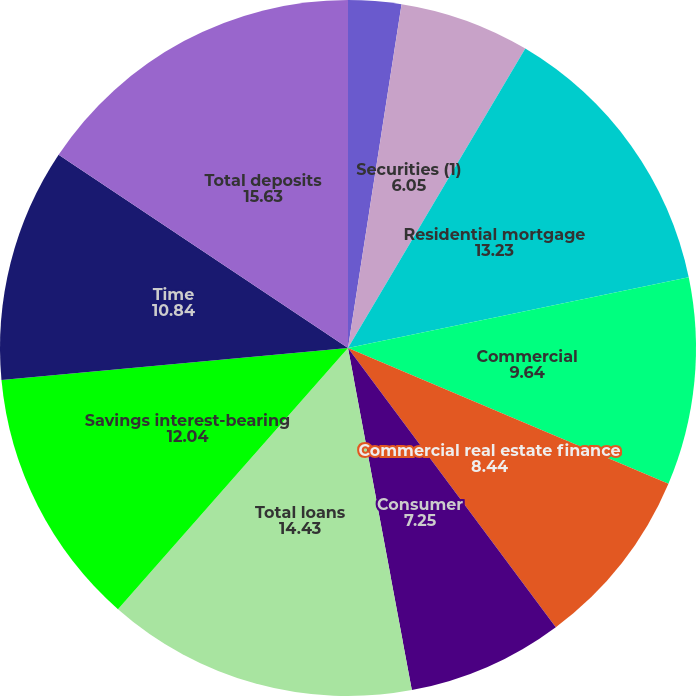<chart> <loc_0><loc_0><loc_500><loc_500><pie_chart><fcel>Short-term investments<fcel>Securities (1)<fcel>Residential mortgage<fcel>Commercial<fcel>Commercial real estate finance<fcel>Consumer<fcel>Total loans<fcel>Savings interest-bearing<fcel>Time<fcel>Total deposits<nl><fcel>2.46%<fcel>6.05%<fcel>13.23%<fcel>9.64%<fcel>8.44%<fcel>7.25%<fcel>14.43%<fcel>12.04%<fcel>10.84%<fcel>15.63%<nl></chart> 